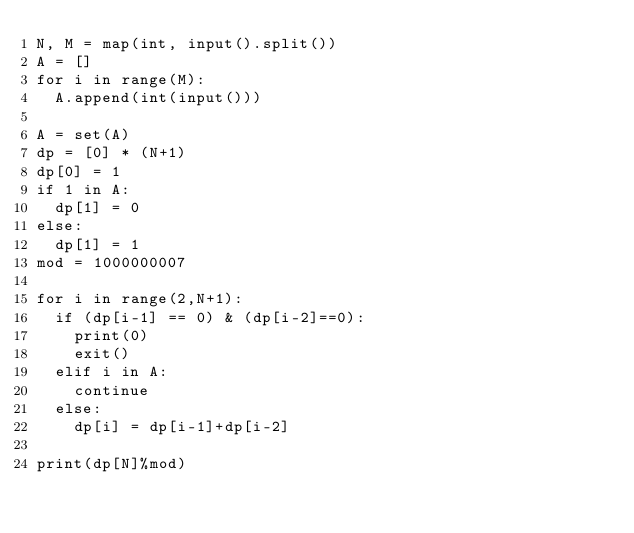Convert code to text. <code><loc_0><loc_0><loc_500><loc_500><_Python_>N, M = map(int, input().split())
A = []
for i in range(M):
  A.append(int(input()))

A = set(A)
dp = [0] * (N+1)
dp[0] = 1
if 1 in A:
  dp[1] = 0
else:
  dp[1] = 1
mod = 1000000007

for i in range(2,N+1):
  if (dp[i-1] == 0) & (dp[i-2]==0):
    print(0)
    exit()
  elif i in A:
    continue
  else:
    dp[i] = dp[i-1]+dp[i-2]

print(dp[N]%mod)
</code> 